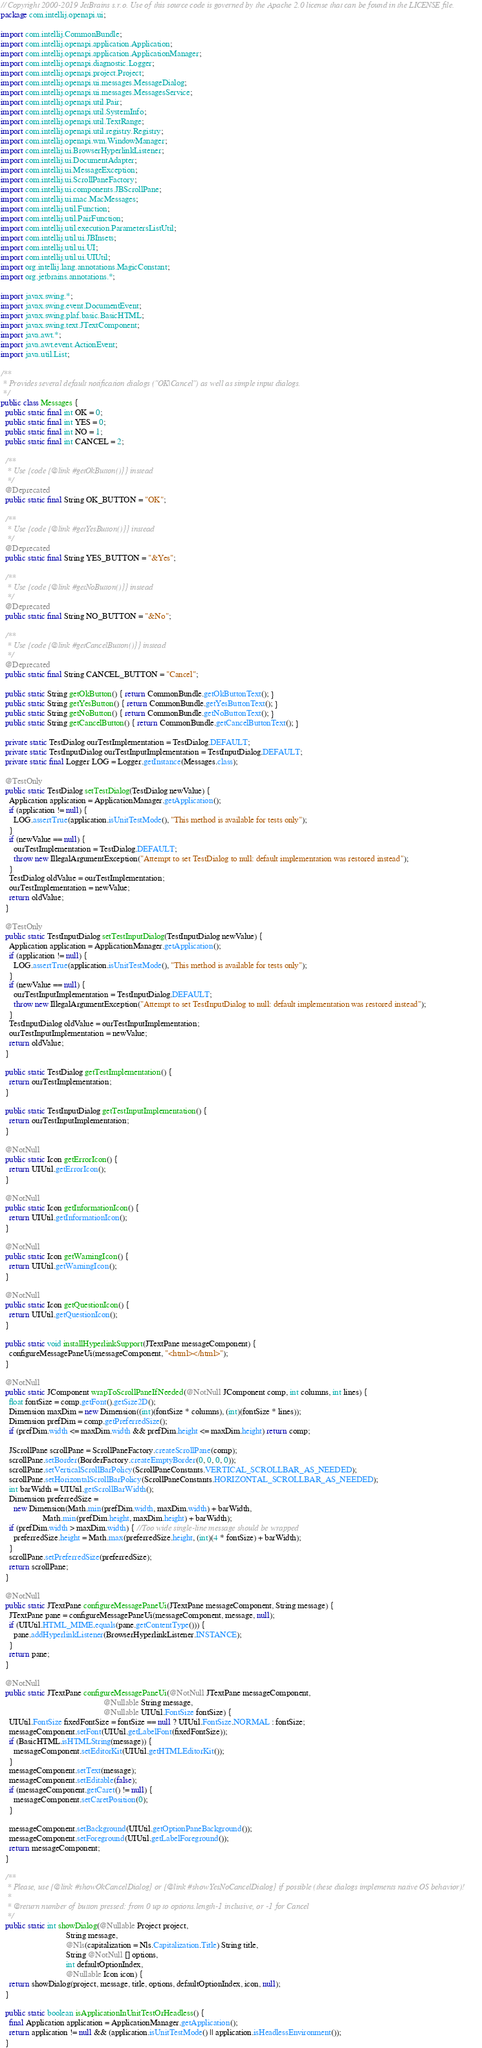Convert code to text. <code><loc_0><loc_0><loc_500><loc_500><_Java_>// Copyright 2000-2019 JetBrains s.r.o. Use of this source code is governed by the Apache 2.0 license that can be found in the LICENSE file.
package com.intellij.openapi.ui;

import com.intellij.CommonBundle;
import com.intellij.openapi.application.Application;
import com.intellij.openapi.application.ApplicationManager;
import com.intellij.openapi.diagnostic.Logger;
import com.intellij.openapi.project.Project;
import com.intellij.openapi.ui.messages.MessageDialog;
import com.intellij.openapi.ui.messages.MessagesService;
import com.intellij.openapi.util.Pair;
import com.intellij.openapi.util.SystemInfo;
import com.intellij.openapi.util.TextRange;
import com.intellij.openapi.util.registry.Registry;
import com.intellij.openapi.wm.WindowManager;
import com.intellij.ui.BrowserHyperlinkListener;
import com.intellij.ui.DocumentAdapter;
import com.intellij.ui.MessageException;
import com.intellij.ui.ScrollPaneFactory;
import com.intellij.ui.components.JBScrollPane;
import com.intellij.ui.mac.MacMessages;
import com.intellij.util.Function;
import com.intellij.util.PairFunction;
import com.intellij.util.execution.ParametersListUtil;
import com.intellij.util.ui.JBInsets;
import com.intellij.util.ui.UI;
import com.intellij.util.ui.UIUtil;
import org.intellij.lang.annotations.MagicConstant;
import org.jetbrains.annotations.*;

import javax.swing.*;
import javax.swing.event.DocumentEvent;
import javax.swing.plaf.basic.BasicHTML;
import javax.swing.text.JTextComponent;
import java.awt.*;
import java.awt.event.ActionEvent;
import java.util.List;

/**
 * Provides several default notification dialogs ("OK|Cancel") as well as simple input dialogs.
 */
public class Messages {
  public static final int OK = 0;
  public static final int YES = 0;
  public static final int NO = 1;
  public static final int CANCEL = 2;

  /**
   * Use {code {@link #getOkButton()}} instead
   */
  @Deprecated
  public static final String OK_BUTTON = "OK";

  /**
   * Use {code {@link #getYesButton()}} instead
   */
  @Deprecated
  public static final String YES_BUTTON = "&Yes";

  /**
   * Use {code {@link #getNoButton()}} instead
   */
  @Deprecated
  public static final String NO_BUTTON = "&No";

  /**
   * Use {code {@link #getCancelButton()}} instead
   */
  @Deprecated
  public static final String CANCEL_BUTTON = "Cancel";

  public static String getOkButton() { return CommonBundle.getOkButtonText(); }
  public static String getYesButton() { return CommonBundle.getYesButtonText(); }
  public static String getNoButton() { return CommonBundle.getNoButtonText(); }
  public static String getCancelButton() { return CommonBundle.getCancelButtonText(); }

  private static TestDialog ourTestImplementation = TestDialog.DEFAULT;
  private static TestInputDialog ourTestInputImplementation = TestInputDialog.DEFAULT;
  private static final Logger LOG = Logger.getInstance(Messages.class);

  @TestOnly
  public static TestDialog setTestDialog(TestDialog newValue) {
    Application application = ApplicationManager.getApplication();
    if (application != null) {
      LOG.assertTrue(application.isUnitTestMode(), "This method is available for tests only");
    }
    if (newValue == null) {
      ourTestImplementation = TestDialog.DEFAULT;
      throw new IllegalArgumentException("Attempt to set TestDialog to null: default implementation was restored instead");
    }
    TestDialog oldValue = ourTestImplementation;
    ourTestImplementation = newValue;
    return oldValue;
  }

  @TestOnly
  public static TestInputDialog setTestInputDialog(TestInputDialog newValue) {
    Application application = ApplicationManager.getApplication();
    if (application != null) {
      LOG.assertTrue(application.isUnitTestMode(), "This method is available for tests only");
    }
    if (newValue == null) {
      ourTestInputImplementation = TestInputDialog.DEFAULT;
      throw new IllegalArgumentException("Attempt to set TestInputDialog to null: default implementation was restored instead");
    }
    TestInputDialog oldValue = ourTestInputImplementation;
    ourTestInputImplementation = newValue;
    return oldValue;
  }

  public static TestDialog getTestImplementation() {
    return ourTestImplementation;
  }

  public static TestInputDialog getTestInputImplementation() {
    return ourTestInputImplementation;
  }

  @NotNull
  public static Icon getErrorIcon() {
    return UIUtil.getErrorIcon();
  }

  @NotNull
  public static Icon getInformationIcon() {
    return UIUtil.getInformationIcon();
  }

  @NotNull
  public static Icon getWarningIcon() {
    return UIUtil.getWarningIcon();
  }

  @NotNull
  public static Icon getQuestionIcon() {
    return UIUtil.getQuestionIcon();
  }

  public static void installHyperlinkSupport(JTextPane messageComponent) {
    configureMessagePaneUi(messageComponent, "<html></html>");
  }

  @NotNull
  public static JComponent wrapToScrollPaneIfNeeded(@NotNull JComponent comp, int columns, int lines) {
    float fontSize = comp.getFont().getSize2D();
    Dimension maxDim = new Dimension((int)(fontSize * columns), (int)(fontSize * lines));
    Dimension prefDim = comp.getPreferredSize();
    if (prefDim.width <= maxDim.width && prefDim.height <= maxDim.height) return comp;

    JScrollPane scrollPane = ScrollPaneFactory.createScrollPane(comp);
    scrollPane.setBorder(BorderFactory.createEmptyBorder(0, 0, 0, 0));
    scrollPane.setVerticalScrollBarPolicy(ScrollPaneConstants.VERTICAL_SCROLLBAR_AS_NEEDED);
    scrollPane.setHorizontalScrollBarPolicy(ScrollPaneConstants.HORIZONTAL_SCROLLBAR_AS_NEEDED);
    int barWidth = UIUtil.getScrollBarWidth();
    Dimension preferredSize =
      new Dimension(Math.min(prefDim.width, maxDim.width) + barWidth,
                    Math.min(prefDim.height, maxDim.height) + barWidth);
    if (prefDim.width > maxDim.width) { //Too wide single-line message should be wrapped
      preferredSize.height = Math.max(preferredSize.height, (int)(4 * fontSize) + barWidth);
    }
    scrollPane.setPreferredSize(preferredSize);
    return scrollPane;
  }

  @NotNull
  public static JTextPane configureMessagePaneUi(JTextPane messageComponent, String message) {
    JTextPane pane = configureMessagePaneUi(messageComponent, message, null);
    if (UIUtil.HTML_MIME.equals(pane.getContentType())) {
      pane.addHyperlinkListener(BrowserHyperlinkListener.INSTANCE);
    }
    return pane;
  }

  @NotNull
  public static JTextPane configureMessagePaneUi(@NotNull JTextPane messageComponent,
                                                 @Nullable String message,
                                                 @Nullable UIUtil.FontSize fontSize) {
    UIUtil.FontSize fixedFontSize = fontSize == null ? UIUtil.FontSize.NORMAL : fontSize;
    messageComponent.setFont(UIUtil.getLabelFont(fixedFontSize));
    if (BasicHTML.isHTMLString(message)) {
      messageComponent.setEditorKit(UIUtil.getHTMLEditorKit());
    }
    messageComponent.setText(message);
    messageComponent.setEditable(false);
    if (messageComponent.getCaret() != null) {
      messageComponent.setCaretPosition(0);
    }

    messageComponent.setBackground(UIUtil.getOptionPaneBackground());
    messageComponent.setForeground(UIUtil.getLabelForeground());
    return messageComponent;
  }

  /**
   * Please, use {@link #showOkCancelDialog} or {@link #showYesNoCancelDialog} if possible (these dialogs implements native OS behavior)!
   *
   * @return number of button pressed: from 0 up to options.length-1 inclusive, or -1 for Cancel
   */
  public static int showDialog(@Nullable Project project,
                               String message,
                               @Nls(capitalization = Nls.Capitalization.Title) String title,
                               String @NotNull [] options,
                               int defaultOptionIndex,
                               @Nullable Icon icon) {
    return showDialog(project, message, title, options, defaultOptionIndex, icon, null);
  }

  public static boolean isApplicationInUnitTestOrHeadless() {
    final Application application = ApplicationManager.getApplication();
    return application != null && (application.isUnitTestMode() || application.isHeadlessEnvironment());
  }
</code> 